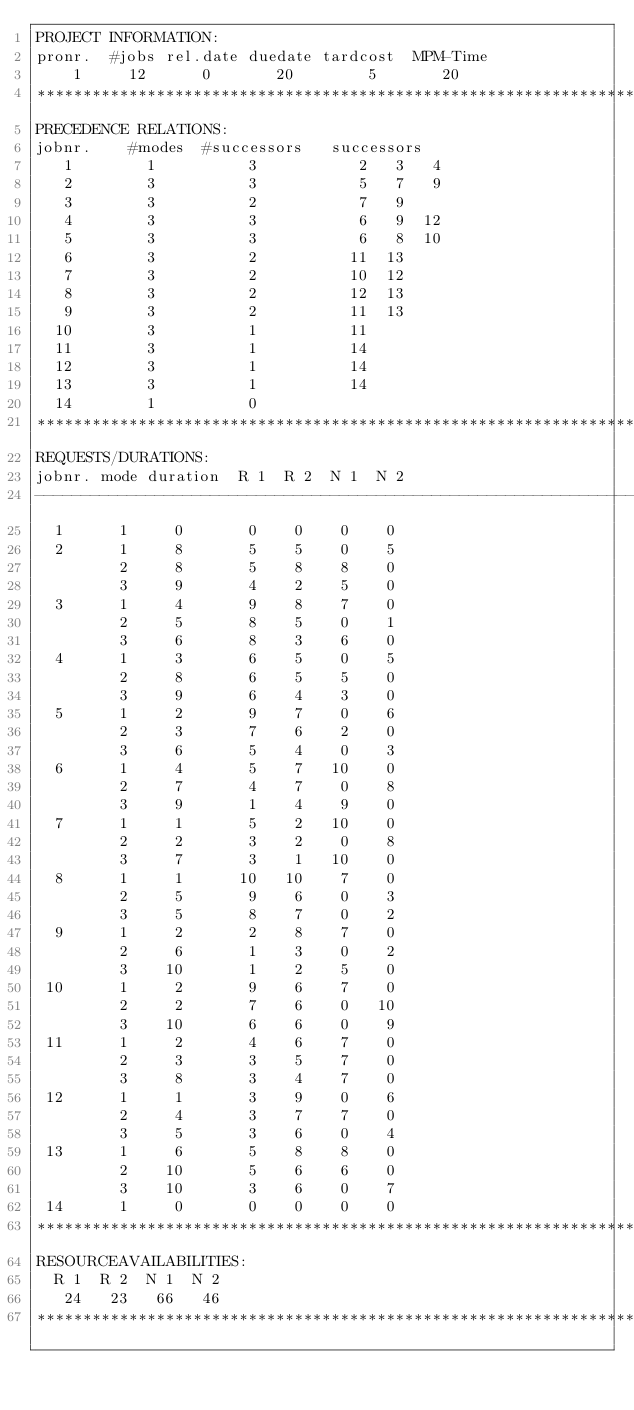<code> <loc_0><loc_0><loc_500><loc_500><_ObjectiveC_>PROJECT INFORMATION:
pronr.  #jobs rel.date duedate tardcost  MPM-Time
    1     12      0       20        5       20
************************************************************************
PRECEDENCE RELATIONS:
jobnr.    #modes  #successors   successors
   1        1          3           2   3   4
   2        3          3           5   7   9
   3        3          2           7   9
   4        3          3           6   9  12
   5        3          3           6   8  10
   6        3          2          11  13
   7        3          2          10  12
   8        3          2          12  13
   9        3          2          11  13
  10        3          1          11
  11        3          1          14
  12        3          1          14
  13        3          1          14
  14        1          0        
************************************************************************
REQUESTS/DURATIONS:
jobnr. mode duration  R 1  R 2  N 1  N 2
------------------------------------------------------------------------
  1      1     0       0    0    0    0
  2      1     8       5    5    0    5
         2     8       5    8    8    0
         3     9       4    2    5    0
  3      1     4       9    8    7    0
         2     5       8    5    0    1
         3     6       8    3    6    0
  4      1     3       6    5    0    5
         2     8       6    5    5    0
         3     9       6    4    3    0
  5      1     2       9    7    0    6
         2     3       7    6    2    0
         3     6       5    4    0    3
  6      1     4       5    7   10    0
         2     7       4    7    0    8
         3     9       1    4    9    0
  7      1     1       5    2   10    0
         2     2       3    2    0    8
         3     7       3    1   10    0
  8      1     1      10   10    7    0
         2     5       9    6    0    3
         3     5       8    7    0    2
  9      1     2       2    8    7    0
         2     6       1    3    0    2
         3    10       1    2    5    0
 10      1     2       9    6    7    0
         2     2       7    6    0   10
         3    10       6    6    0    9
 11      1     2       4    6    7    0
         2     3       3    5    7    0
         3     8       3    4    7    0
 12      1     1       3    9    0    6
         2     4       3    7    7    0
         3     5       3    6    0    4
 13      1     6       5    8    8    0
         2    10       5    6    6    0
         3    10       3    6    0    7
 14      1     0       0    0    0    0
************************************************************************
RESOURCEAVAILABILITIES:
  R 1  R 2  N 1  N 2
   24   23   66   46
************************************************************************
</code> 